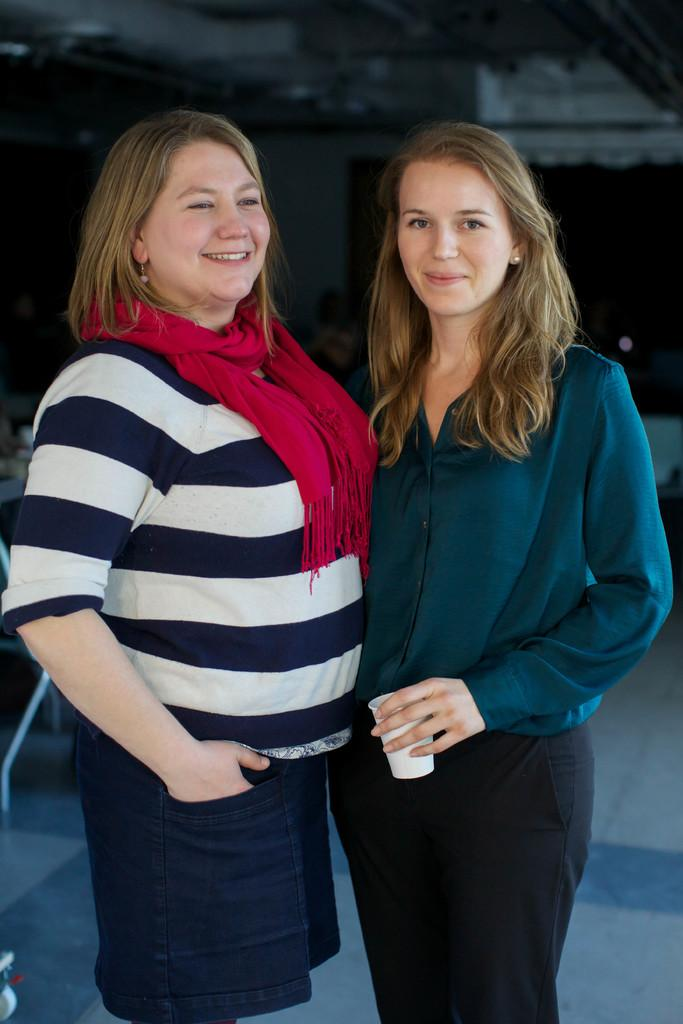How many women are in the image? There are two women in the image. What are the women doing in the image? The women are standing and posing for a photo. Can you describe the background of the image? The background of the image is blurry. What type of quartz can be seen in the image? There is no quartz present in the image. Can you tell me how many eyes are visible in the image? The number of eyes visible in the image depends on the number of women and their facial expressions, but it is not possible to determine the exact number from the image alone. --- Facts: 1. There is a car in the image. 2. The car is parked on the street. 3. There are streetlights in the image. 4. The streetlights are turned on. 5. There are buildings in the background of the image. Absurd Topics: ocean, parrot, volcano Conversation: What is the main subject of the image? The main subject of the image is a car. Where is the car located in the image? The car is parked on the street. What other objects can be seen in the image? Streetlights are visible in the image. Can you describe the condition of the streetlights? The streetlights are turned on. What is visible in the background of the image? There are buildings in the background of the image. Reasoning: Let's think step by step in order to produce the conversation. We start by identifying the main subject of the image, which is the car. Then, we describe the car's location, noting that it is parked on the street. Next, we mention other objects in the image, such as the streetlights. We then describe the condition of the streetlights, noting that they are turned on. Finally, we describe the background of the image, which includes buildings. Absurd Question/Answer: Can you tell me how many parrots are sitting on the car in the image? There are no parrots present in the image. What type of volcano can be seen erupting in the background of the image? There is no volcano present in the image; it features a car parked on the street with streetlights and buildings in the background. 